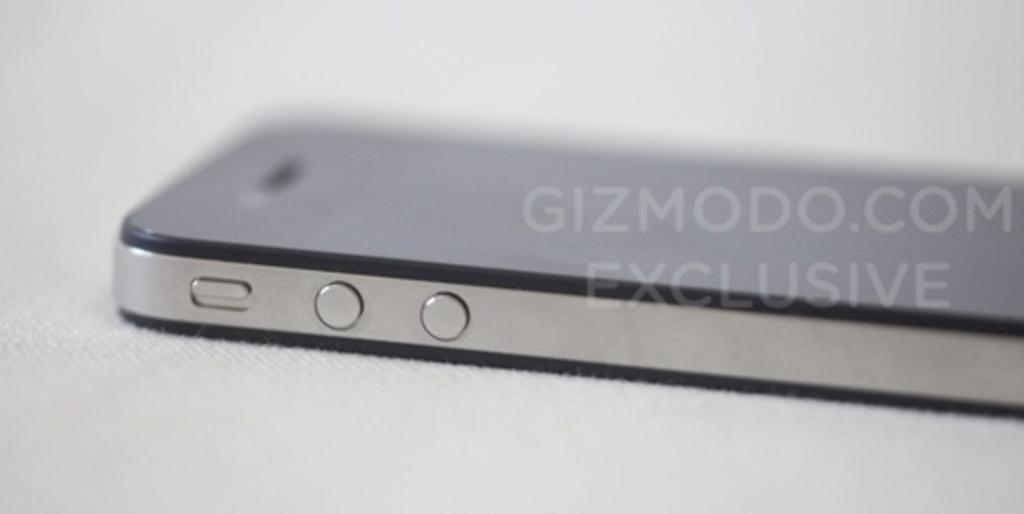<image>
Describe the image concisely. A view of a phone is marked as a Gizmodo exclusive. 